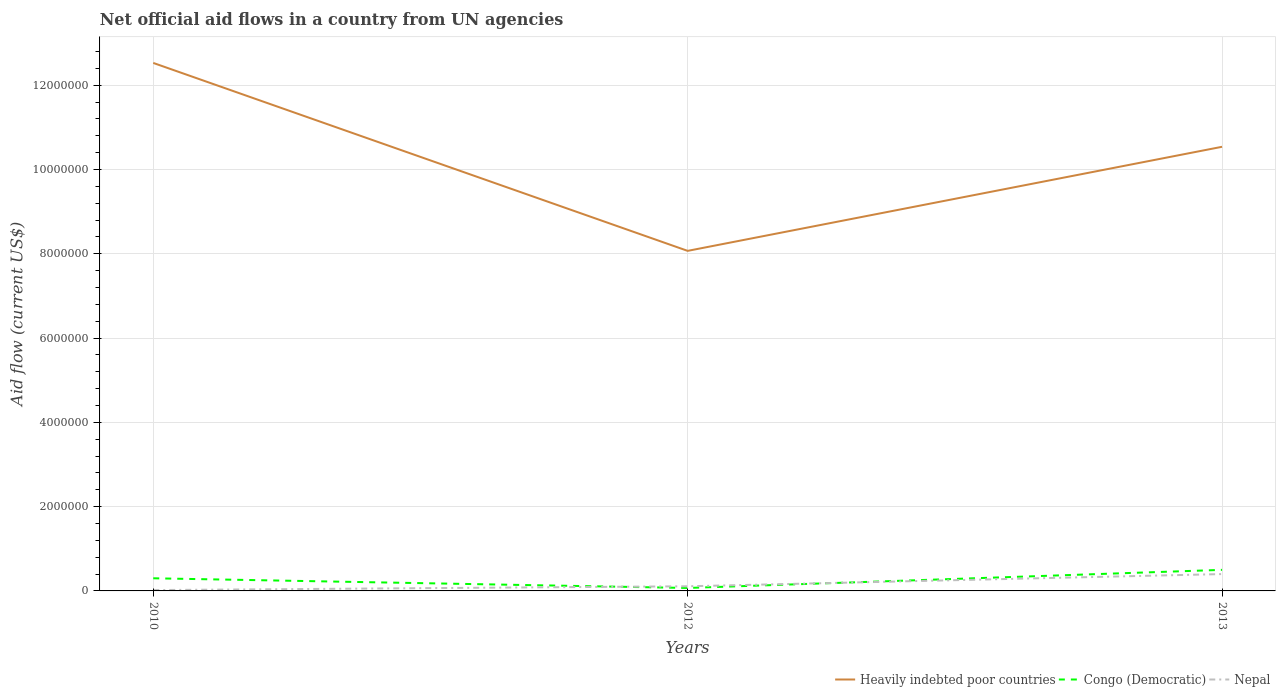How many different coloured lines are there?
Keep it short and to the point. 3. Is the number of lines equal to the number of legend labels?
Offer a very short reply. Yes. Across all years, what is the maximum net official aid flow in Nepal?
Offer a very short reply. 2.00e+04. What is the total net official aid flow in Congo (Democratic) in the graph?
Offer a very short reply. -2.00e+05. What is the difference between the highest and the second highest net official aid flow in Nepal?
Ensure brevity in your answer.  3.80e+05. Is the net official aid flow in Congo (Democratic) strictly greater than the net official aid flow in Heavily indebted poor countries over the years?
Give a very brief answer. Yes. How many lines are there?
Your answer should be compact. 3. How many years are there in the graph?
Provide a short and direct response. 3. What is the difference between two consecutive major ticks on the Y-axis?
Your answer should be very brief. 2.00e+06. Does the graph contain any zero values?
Offer a terse response. No. Where does the legend appear in the graph?
Give a very brief answer. Bottom right. How many legend labels are there?
Ensure brevity in your answer.  3. What is the title of the graph?
Offer a terse response. Net official aid flows in a country from UN agencies. What is the Aid flow (current US$) of Heavily indebted poor countries in 2010?
Ensure brevity in your answer.  1.25e+07. What is the Aid flow (current US$) in Congo (Democratic) in 2010?
Provide a succinct answer. 3.00e+05. What is the Aid flow (current US$) in Nepal in 2010?
Give a very brief answer. 2.00e+04. What is the Aid flow (current US$) in Heavily indebted poor countries in 2012?
Your answer should be compact. 8.07e+06. What is the Aid flow (current US$) of Nepal in 2012?
Ensure brevity in your answer.  1.10e+05. What is the Aid flow (current US$) of Heavily indebted poor countries in 2013?
Your response must be concise. 1.05e+07. What is the Aid flow (current US$) of Congo (Democratic) in 2013?
Make the answer very short. 5.00e+05. What is the Aid flow (current US$) of Nepal in 2013?
Keep it short and to the point. 4.00e+05. Across all years, what is the maximum Aid flow (current US$) in Heavily indebted poor countries?
Your answer should be compact. 1.25e+07. Across all years, what is the minimum Aid flow (current US$) in Heavily indebted poor countries?
Make the answer very short. 8.07e+06. Across all years, what is the minimum Aid flow (current US$) of Nepal?
Your answer should be compact. 2.00e+04. What is the total Aid flow (current US$) of Heavily indebted poor countries in the graph?
Provide a short and direct response. 3.11e+07. What is the total Aid flow (current US$) in Congo (Democratic) in the graph?
Offer a very short reply. 8.70e+05. What is the total Aid flow (current US$) of Nepal in the graph?
Provide a short and direct response. 5.30e+05. What is the difference between the Aid flow (current US$) in Heavily indebted poor countries in 2010 and that in 2012?
Give a very brief answer. 4.46e+06. What is the difference between the Aid flow (current US$) in Heavily indebted poor countries in 2010 and that in 2013?
Keep it short and to the point. 1.99e+06. What is the difference between the Aid flow (current US$) in Nepal in 2010 and that in 2013?
Provide a short and direct response. -3.80e+05. What is the difference between the Aid flow (current US$) in Heavily indebted poor countries in 2012 and that in 2013?
Keep it short and to the point. -2.47e+06. What is the difference between the Aid flow (current US$) of Congo (Democratic) in 2012 and that in 2013?
Provide a succinct answer. -4.30e+05. What is the difference between the Aid flow (current US$) of Nepal in 2012 and that in 2013?
Your response must be concise. -2.90e+05. What is the difference between the Aid flow (current US$) in Heavily indebted poor countries in 2010 and the Aid flow (current US$) in Congo (Democratic) in 2012?
Your answer should be compact. 1.25e+07. What is the difference between the Aid flow (current US$) in Heavily indebted poor countries in 2010 and the Aid flow (current US$) in Nepal in 2012?
Provide a succinct answer. 1.24e+07. What is the difference between the Aid flow (current US$) of Heavily indebted poor countries in 2010 and the Aid flow (current US$) of Congo (Democratic) in 2013?
Provide a succinct answer. 1.20e+07. What is the difference between the Aid flow (current US$) in Heavily indebted poor countries in 2010 and the Aid flow (current US$) in Nepal in 2013?
Ensure brevity in your answer.  1.21e+07. What is the difference between the Aid flow (current US$) in Heavily indebted poor countries in 2012 and the Aid flow (current US$) in Congo (Democratic) in 2013?
Keep it short and to the point. 7.57e+06. What is the difference between the Aid flow (current US$) of Heavily indebted poor countries in 2012 and the Aid flow (current US$) of Nepal in 2013?
Provide a succinct answer. 7.67e+06. What is the difference between the Aid flow (current US$) of Congo (Democratic) in 2012 and the Aid flow (current US$) of Nepal in 2013?
Ensure brevity in your answer.  -3.30e+05. What is the average Aid flow (current US$) of Heavily indebted poor countries per year?
Provide a succinct answer. 1.04e+07. What is the average Aid flow (current US$) of Nepal per year?
Your response must be concise. 1.77e+05. In the year 2010, what is the difference between the Aid flow (current US$) of Heavily indebted poor countries and Aid flow (current US$) of Congo (Democratic)?
Keep it short and to the point. 1.22e+07. In the year 2010, what is the difference between the Aid flow (current US$) in Heavily indebted poor countries and Aid flow (current US$) in Nepal?
Make the answer very short. 1.25e+07. In the year 2010, what is the difference between the Aid flow (current US$) in Congo (Democratic) and Aid flow (current US$) in Nepal?
Provide a succinct answer. 2.80e+05. In the year 2012, what is the difference between the Aid flow (current US$) in Heavily indebted poor countries and Aid flow (current US$) in Nepal?
Make the answer very short. 7.96e+06. In the year 2012, what is the difference between the Aid flow (current US$) in Congo (Democratic) and Aid flow (current US$) in Nepal?
Offer a terse response. -4.00e+04. In the year 2013, what is the difference between the Aid flow (current US$) of Heavily indebted poor countries and Aid flow (current US$) of Congo (Democratic)?
Make the answer very short. 1.00e+07. In the year 2013, what is the difference between the Aid flow (current US$) in Heavily indebted poor countries and Aid flow (current US$) in Nepal?
Offer a terse response. 1.01e+07. What is the ratio of the Aid flow (current US$) of Heavily indebted poor countries in 2010 to that in 2012?
Give a very brief answer. 1.55. What is the ratio of the Aid flow (current US$) of Congo (Democratic) in 2010 to that in 2012?
Your answer should be compact. 4.29. What is the ratio of the Aid flow (current US$) in Nepal in 2010 to that in 2012?
Keep it short and to the point. 0.18. What is the ratio of the Aid flow (current US$) in Heavily indebted poor countries in 2010 to that in 2013?
Make the answer very short. 1.19. What is the ratio of the Aid flow (current US$) of Congo (Democratic) in 2010 to that in 2013?
Provide a short and direct response. 0.6. What is the ratio of the Aid flow (current US$) of Nepal in 2010 to that in 2013?
Offer a terse response. 0.05. What is the ratio of the Aid flow (current US$) in Heavily indebted poor countries in 2012 to that in 2013?
Give a very brief answer. 0.77. What is the ratio of the Aid flow (current US$) of Congo (Democratic) in 2012 to that in 2013?
Give a very brief answer. 0.14. What is the ratio of the Aid flow (current US$) of Nepal in 2012 to that in 2013?
Make the answer very short. 0.28. What is the difference between the highest and the second highest Aid flow (current US$) of Heavily indebted poor countries?
Give a very brief answer. 1.99e+06. What is the difference between the highest and the lowest Aid flow (current US$) in Heavily indebted poor countries?
Give a very brief answer. 4.46e+06. What is the difference between the highest and the lowest Aid flow (current US$) in Congo (Democratic)?
Keep it short and to the point. 4.30e+05. What is the difference between the highest and the lowest Aid flow (current US$) of Nepal?
Provide a succinct answer. 3.80e+05. 